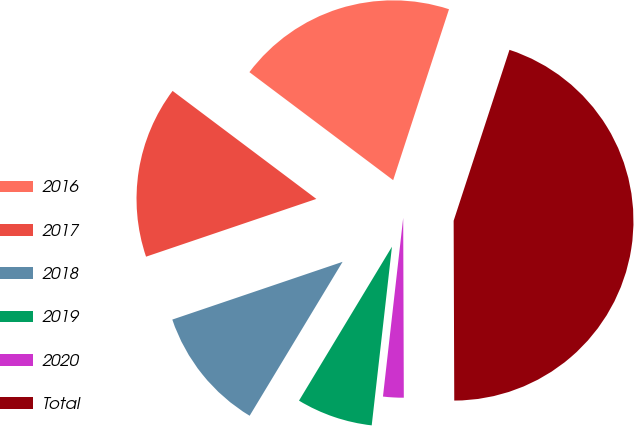Convert chart. <chart><loc_0><loc_0><loc_500><loc_500><pie_chart><fcel>2016<fcel>2017<fcel>2018<fcel>2019<fcel>2020<fcel>Total<nl><fcel>19.77%<fcel>15.46%<fcel>11.15%<fcel>6.85%<fcel>1.85%<fcel>44.92%<nl></chart> 